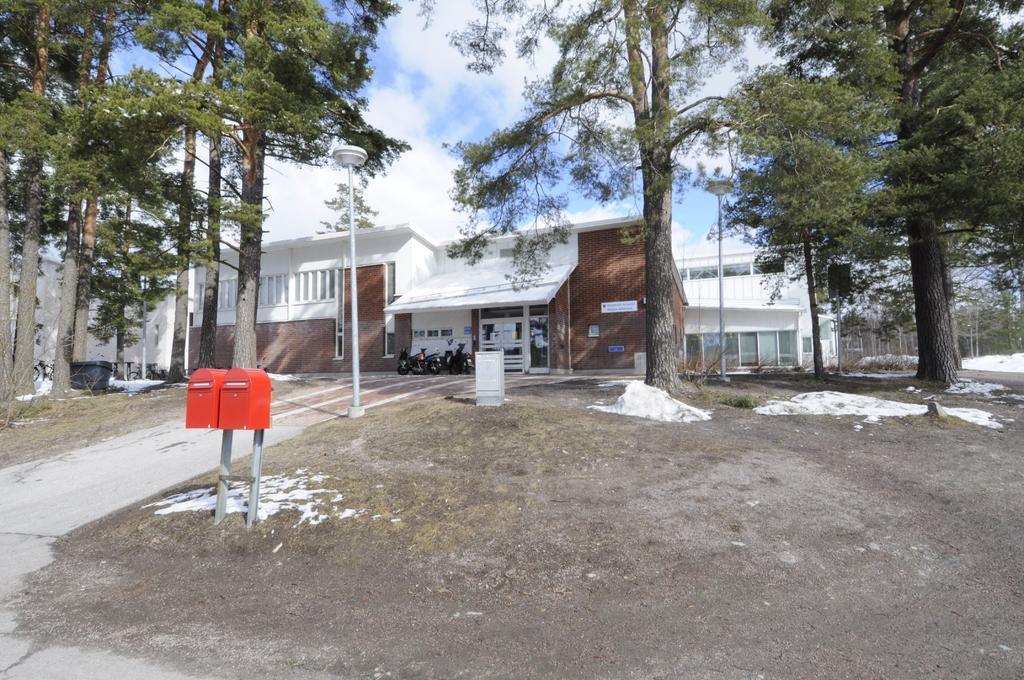Please provide a concise description of this image. This picture shows buildings and we see couple of pole lights and we see trees and couple of mailboxes and a dustbin on the ground and we see a blue cloudy sky. 